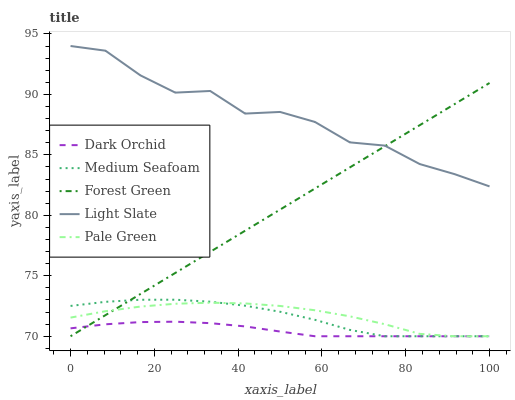Does Dark Orchid have the minimum area under the curve?
Answer yes or no. Yes. Does Light Slate have the maximum area under the curve?
Answer yes or no. Yes. Does Forest Green have the minimum area under the curve?
Answer yes or no. No. Does Forest Green have the maximum area under the curve?
Answer yes or no. No. Is Forest Green the smoothest?
Answer yes or no. Yes. Is Light Slate the roughest?
Answer yes or no. Yes. Is Pale Green the smoothest?
Answer yes or no. No. Is Pale Green the roughest?
Answer yes or no. No. Does Forest Green have the lowest value?
Answer yes or no. Yes. Does Light Slate have the highest value?
Answer yes or no. Yes. Does Forest Green have the highest value?
Answer yes or no. No. Is Medium Seafoam less than Light Slate?
Answer yes or no. Yes. Is Light Slate greater than Pale Green?
Answer yes or no. Yes. Does Forest Green intersect Light Slate?
Answer yes or no. Yes. Is Forest Green less than Light Slate?
Answer yes or no. No. Is Forest Green greater than Light Slate?
Answer yes or no. No. Does Medium Seafoam intersect Light Slate?
Answer yes or no. No. 